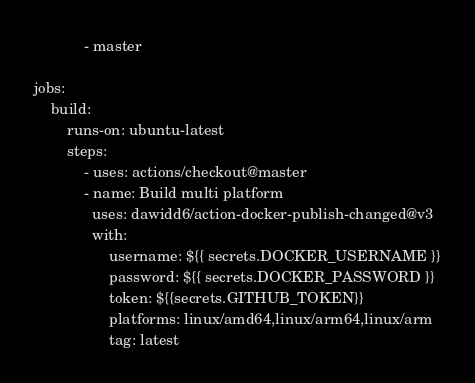Convert code to text. <code><loc_0><loc_0><loc_500><loc_500><_YAML_>            - master

jobs:
    build:
        runs-on: ubuntu-latest
        steps:
            - uses: actions/checkout@master
            - name: Build multi platform
              uses: dawidd6/action-docker-publish-changed@v3
              with:
                  username: ${{ secrets.DOCKER_USERNAME }}
                  password: ${{ secrets.DOCKER_PASSWORD }}
                  token: ${{secrets.GITHUB_TOKEN}}
                  platforms: linux/amd64,linux/arm64,linux/arm
                  tag: latest
</code> 